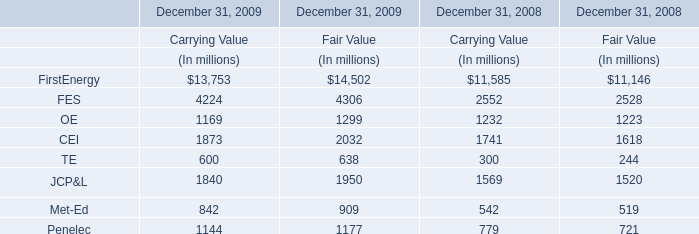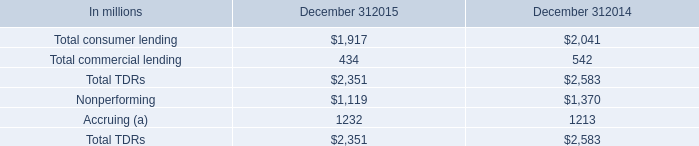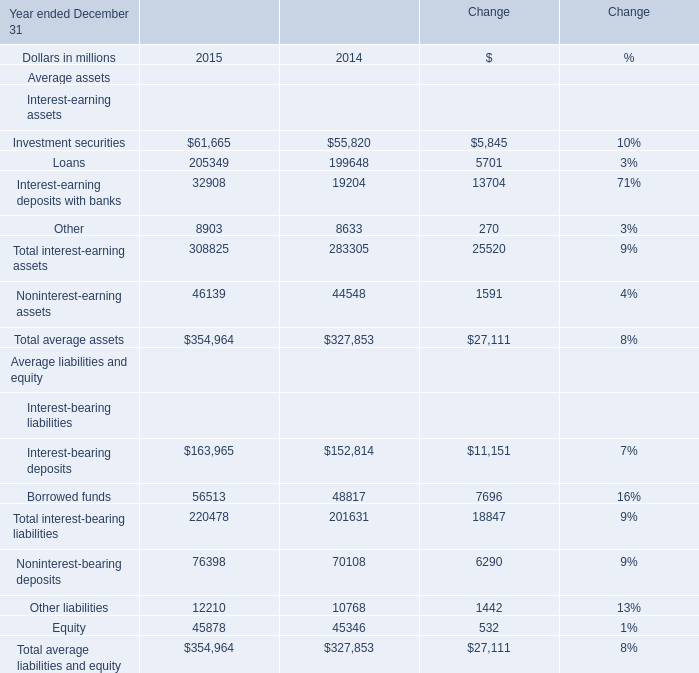For what Year ended December 31 is the value of Total average assets lower than 330000 million? 
Answer: 2014. what was the change in specific reserves in alll between december 31 , 2015 and december 31 , 2014 in billions? 
Computations: (.3 - .4)
Answer: -0.1. 